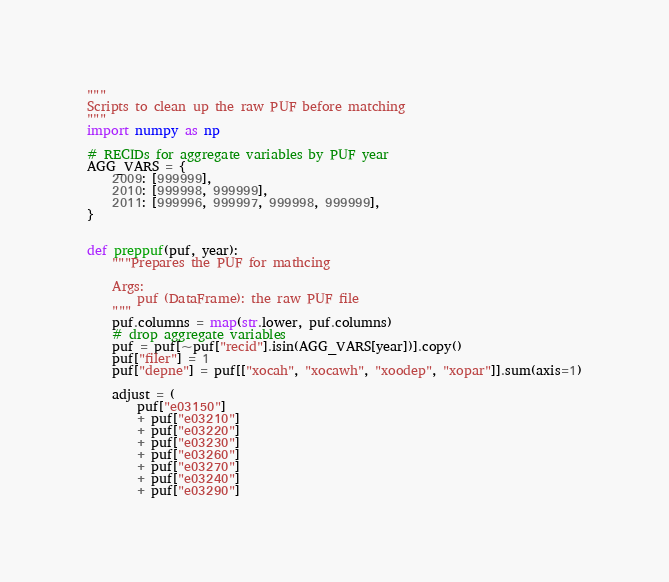Convert code to text. <code><loc_0><loc_0><loc_500><loc_500><_Python_>"""
Scripts to clean up the raw PUF before matching
"""
import numpy as np

# RECIDs for aggregate variables by PUF year
AGG_VARS = {
    2009: [999999],
    2010: [999998, 999999],
    2011: [999996, 999997, 999998, 999999],
}


def preppuf(puf, year):
    """Prepares the PUF for mathcing

    Args:
        puf (DataFrame): the raw PUF file
    """
    puf.columns = map(str.lower, puf.columns)
    # drop aggregate variables
    puf = puf[~puf["recid"].isin(AGG_VARS[year])].copy()
    puf["filer"] = 1
    puf["depne"] = puf[["xocah", "xocawh", "xoodep", "xopar"]].sum(axis=1)

    adjust = (
        puf["e03150"]
        + puf["e03210"]
        + puf["e03220"]
        + puf["e03230"]
        + puf["e03260"]
        + puf["e03270"]
        + puf["e03240"]
        + puf["e03290"]</code> 